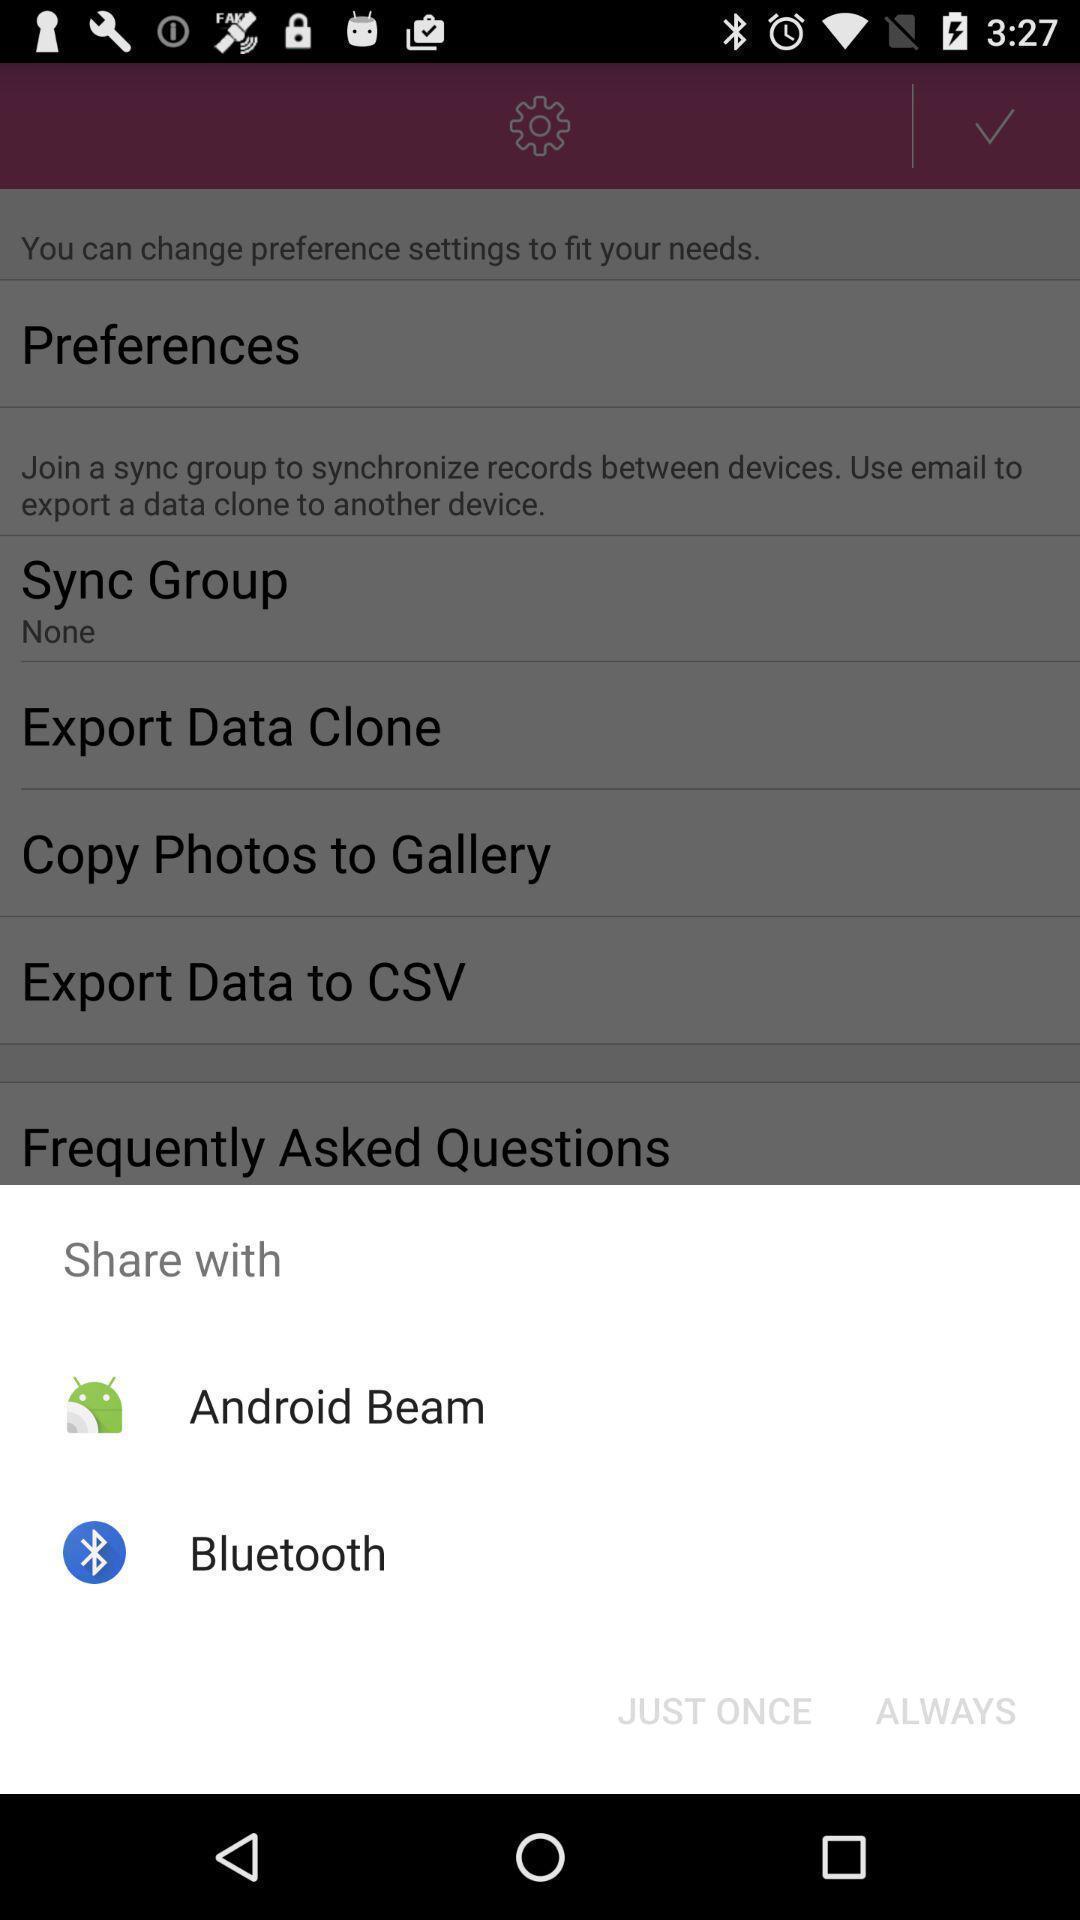Summarize the information in this screenshot. Screen displaying sharing options using different social applications. 